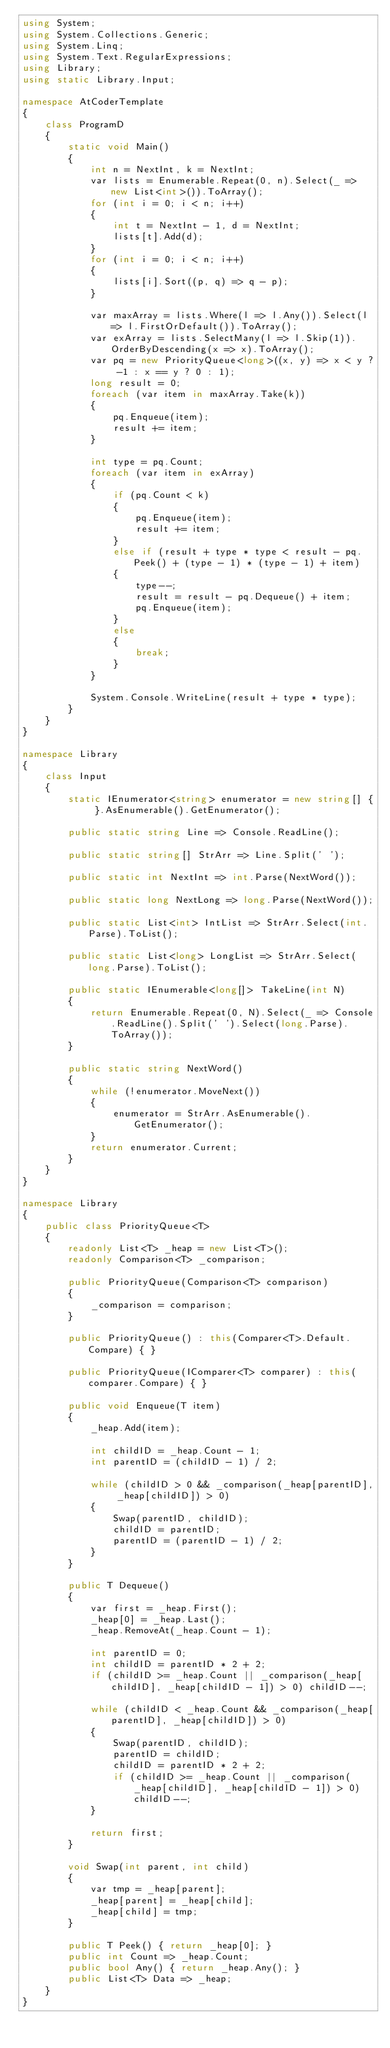Convert code to text. <code><loc_0><loc_0><loc_500><loc_500><_C#_>using System;
using System.Collections.Generic;
using System.Linq;
using System.Text.RegularExpressions;
using Library;
using static Library.Input;

namespace AtCoderTemplate
{
    class ProgramD
    {
        static void Main()
        {
            int n = NextInt, k = NextInt;
            var lists = Enumerable.Repeat(0, n).Select(_ => new List<int>()).ToArray();
            for (int i = 0; i < n; i++)
            {
                int t = NextInt - 1, d = NextInt;
                lists[t].Add(d);
            }
            for (int i = 0; i < n; i++)
            {
                lists[i].Sort((p, q) => q - p);
            }

            var maxArray = lists.Where(l => l.Any()).Select(l => l.FirstOrDefault()).ToArray();
            var exArray = lists.SelectMany(l => l.Skip(1)).OrderByDescending(x => x).ToArray();
            var pq = new PriorityQueue<long>((x, y) => x < y ? -1 : x == y ? 0 : 1);
            long result = 0;
            foreach (var item in maxArray.Take(k))
            {
                pq.Enqueue(item);
                result += item;
            }
            
            int type = pq.Count;
            foreach (var item in exArray)
            {
                if (pq.Count < k)
                {
                    pq.Enqueue(item);
                    result += item;
                }
                else if (result + type * type < result - pq.Peek() + (type - 1) * (type - 1) + item)
                {
                    type--;
                    result = result - pq.Dequeue() + item;
                    pq.Enqueue(item);
                }
                else
                {
                    break;
                }
            }

            System.Console.WriteLine(result + type * type);
        }
    }
}

namespace Library
{
    class Input
    {
        static IEnumerator<string> enumerator = new string[] { }.AsEnumerable().GetEnumerator();

        public static string Line => Console.ReadLine();

        public static string[] StrArr => Line.Split(' ');

        public static int NextInt => int.Parse(NextWord());

        public static long NextLong => long.Parse(NextWord());

        public static List<int> IntList => StrArr.Select(int.Parse).ToList();

        public static List<long> LongList => StrArr.Select(long.Parse).ToList();

        public static IEnumerable<long[]> TakeLine(int N)
        {
            return Enumerable.Repeat(0, N).Select(_ => Console.ReadLine().Split(' ').Select(long.Parse).ToArray());
        }

        public static string NextWord()
        {
            while (!enumerator.MoveNext())
            {
                enumerator = StrArr.AsEnumerable().GetEnumerator();
            }
            return enumerator.Current;
        }
    }
}

namespace Library
{
    public class PriorityQueue<T>
    {
        readonly List<T> _heap = new List<T>();
        readonly Comparison<T> _comparison;

        public PriorityQueue(Comparison<T> comparison)
        {
            _comparison = comparison;
        }

        public PriorityQueue() : this(Comparer<T>.Default.Compare) { }

        public PriorityQueue(IComparer<T> comparer) : this(comparer.Compare) { }

        public void Enqueue(T item)
        {
            _heap.Add(item);

            int childID = _heap.Count - 1;
            int parentID = (childID - 1) / 2;

            while (childID > 0 && _comparison(_heap[parentID], _heap[childID]) > 0)
            {
                Swap(parentID, childID);
                childID = parentID;
                parentID = (parentID - 1) / 2;
            }
        }

        public T Dequeue()
        {
            var first = _heap.First();
            _heap[0] = _heap.Last();
            _heap.RemoveAt(_heap.Count - 1);

            int parentID = 0;
            int childID = parentID * 2 + 2;
            if (childID >= _heap.Count || _comparison(_heap[childID], _heap[childID - 1]) > 0) childID--;

            while (childID < _heap.Count && _comparison(_heap[parentID], _heap[childID]) > 0)
            {
                Swap(parentID, childID);
                parentID = childID;
                childID = parentID * 2 + 2;
                if (childID >= _heap.Count || _comparison(_heap[childID], _heap[childID - 1]) > 0) childID--;
            }

            return first;
        }

        void Swap(int parent, int child)
        {
            var tmp = _heap[parent];
            _heap[parent] = _heap[child];
            _heap[child] = tmp;
        }

        public T Peek() { return _heap[0]; }
        public int Count => _heap.Count;
        public bool Any() { return _heap.Any(); }
        public List<T> Data => _heap;
    }
}
</code> 